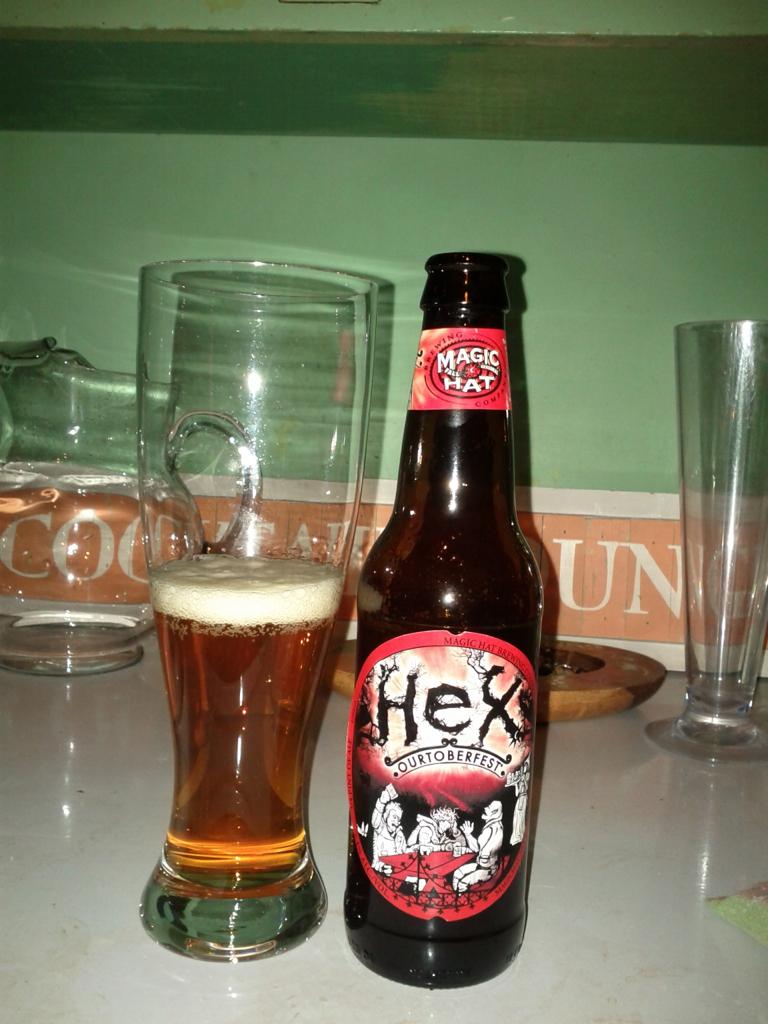What brand is this beer?
Your response must be concise. Hex. What does the top of the bottle say?
Provide a short and direct response. Magic hat. 